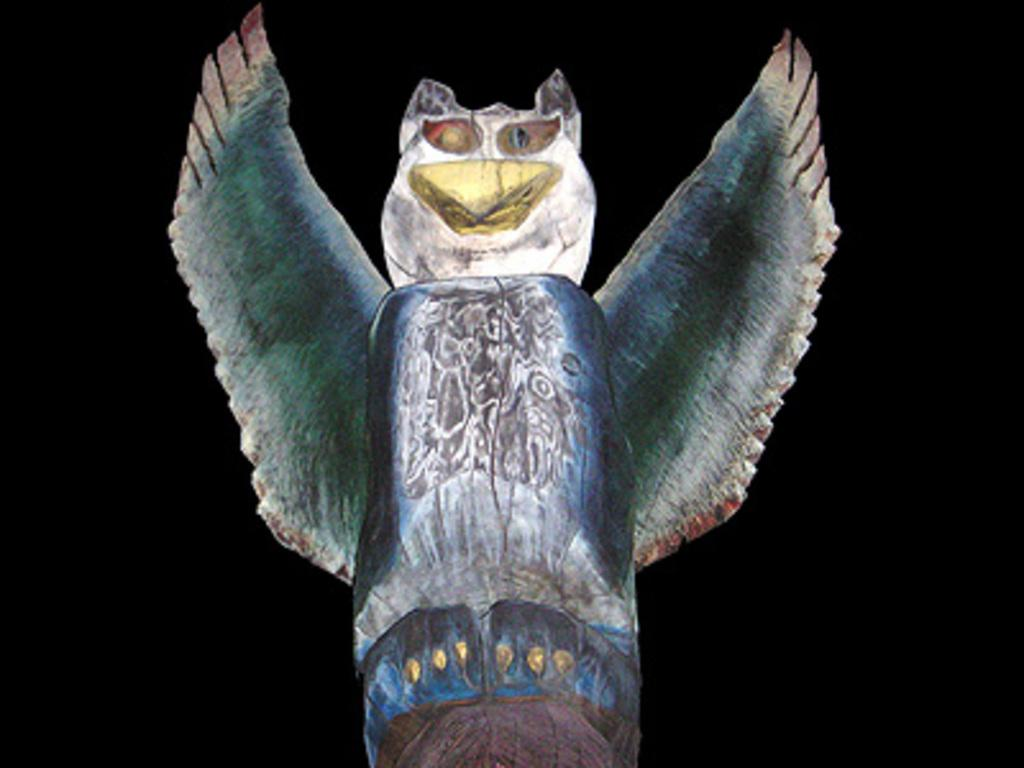What type of animal is depicted in the image? The image contains a picture of an owl. Can you describe the medium of the image? The picture appears to be a painting. What type of noise does the owl make in the image? The image is a painting, and therefore there is no sound or noise present. 